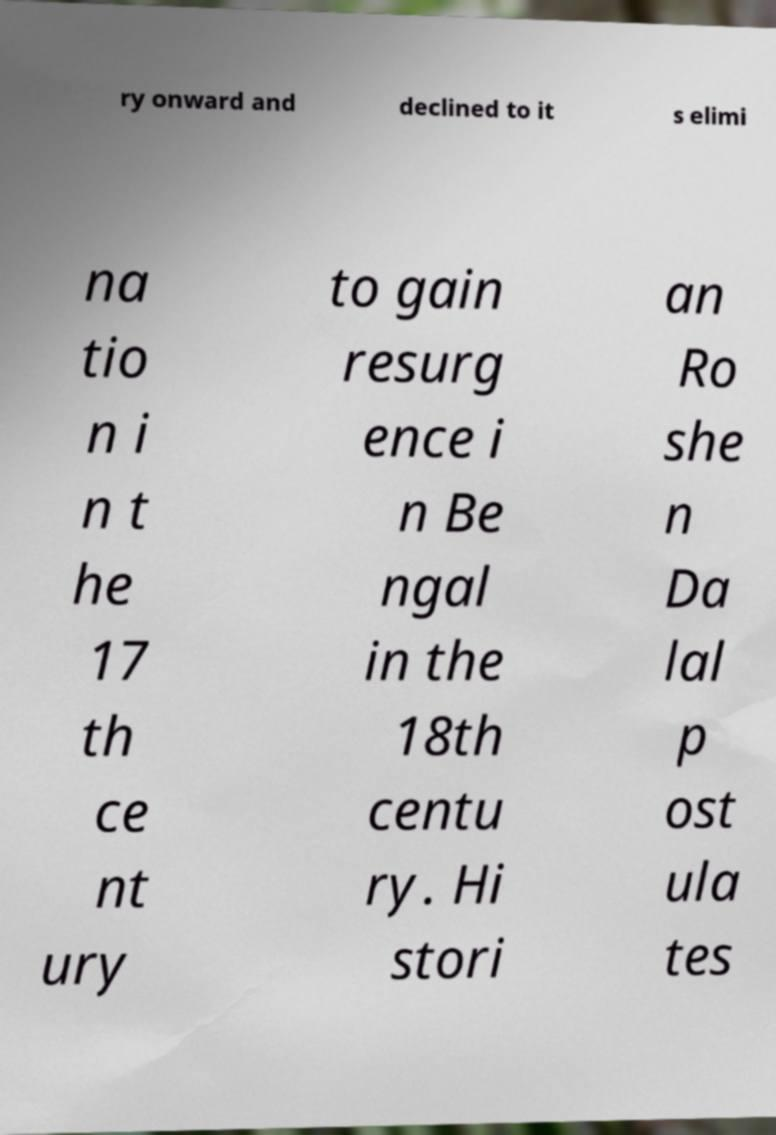Please read and relay the text visible in this image. What does it say? ry onward and declined to it s elimi na tio n i n t he 17 th ce nt ury to gain resurg ence i n Be ngal in the 18th centu ry. Hi stori an Ro she n Da lal p ost ula tes 